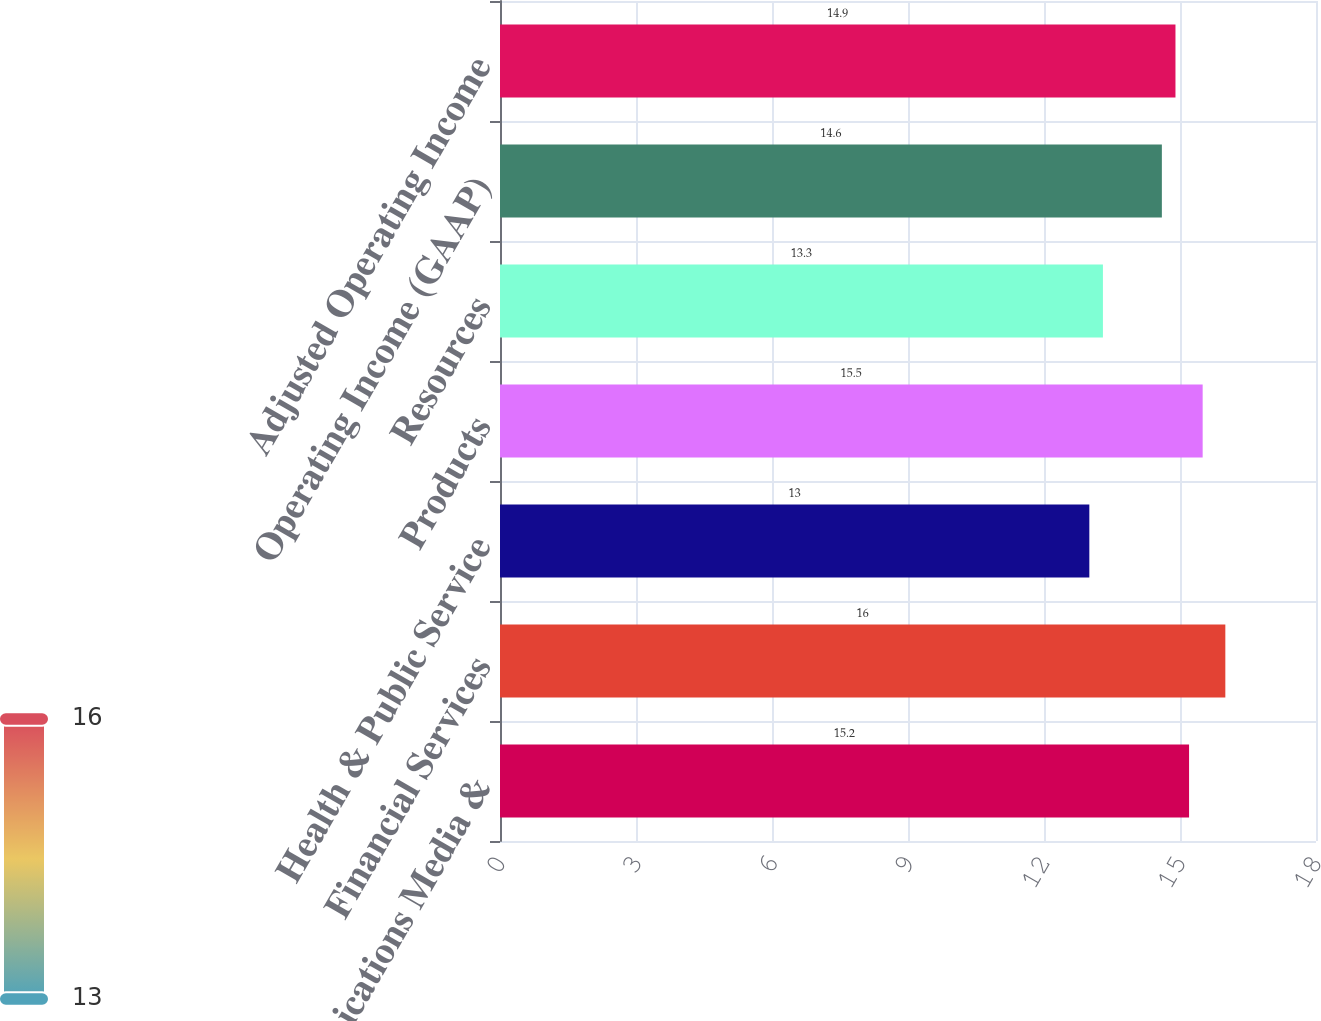<chart> <loc_0><loc_0><loc_500><loc_500><bar_chart><fcel>Communications Media &<fcel>Financial Services<fcel>Health & Public Service<fcel>Products<fcel>Resources<fcel>Operating Income (GAAP)<fcel>Adjusted Operating Income<nl><fcel>15.2<fcel>16<fcel>13<fcel>15.5<fcel>13.3<fcel>14.6<fcel>14.9<nl></chart> 